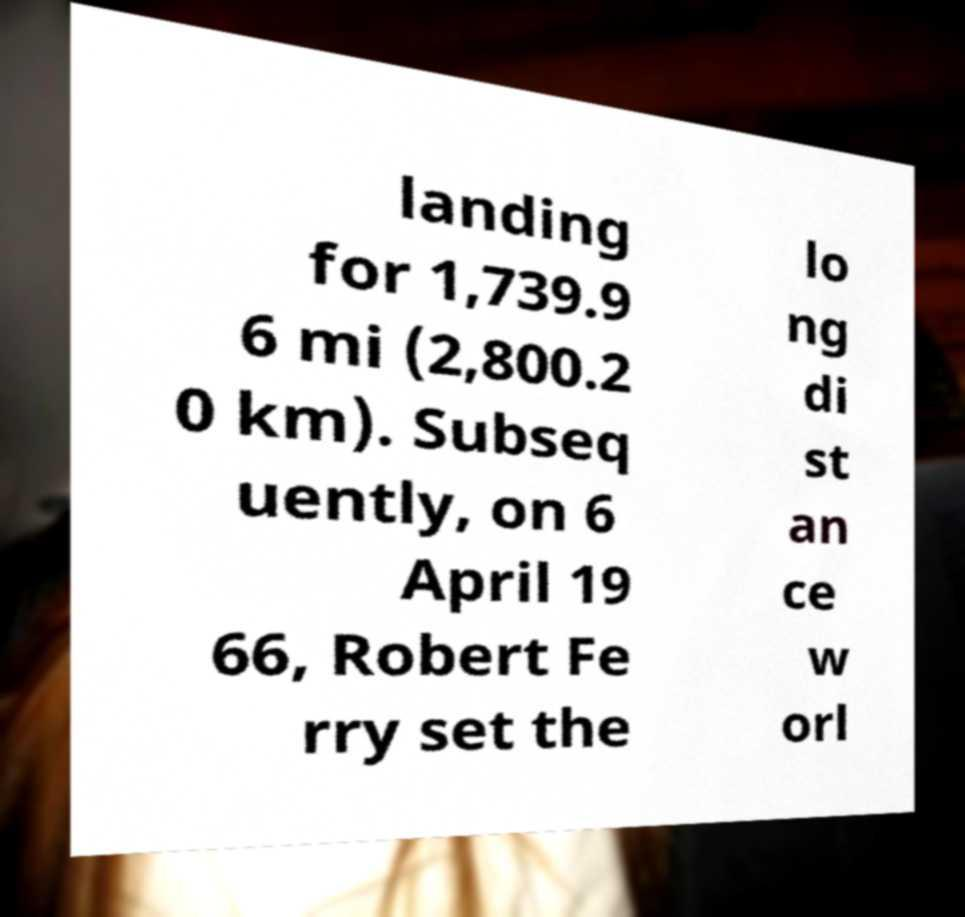Can you read and provide the text displayed in the image?This photo seems to have some interesting text. Can you extract and type it out for me? landing for 1,739.9 6 mi (2,800.2 0 km). Subseq uently, on 6 April 19 66, Robert Fe rry set the lo ng di st an ce w orl 